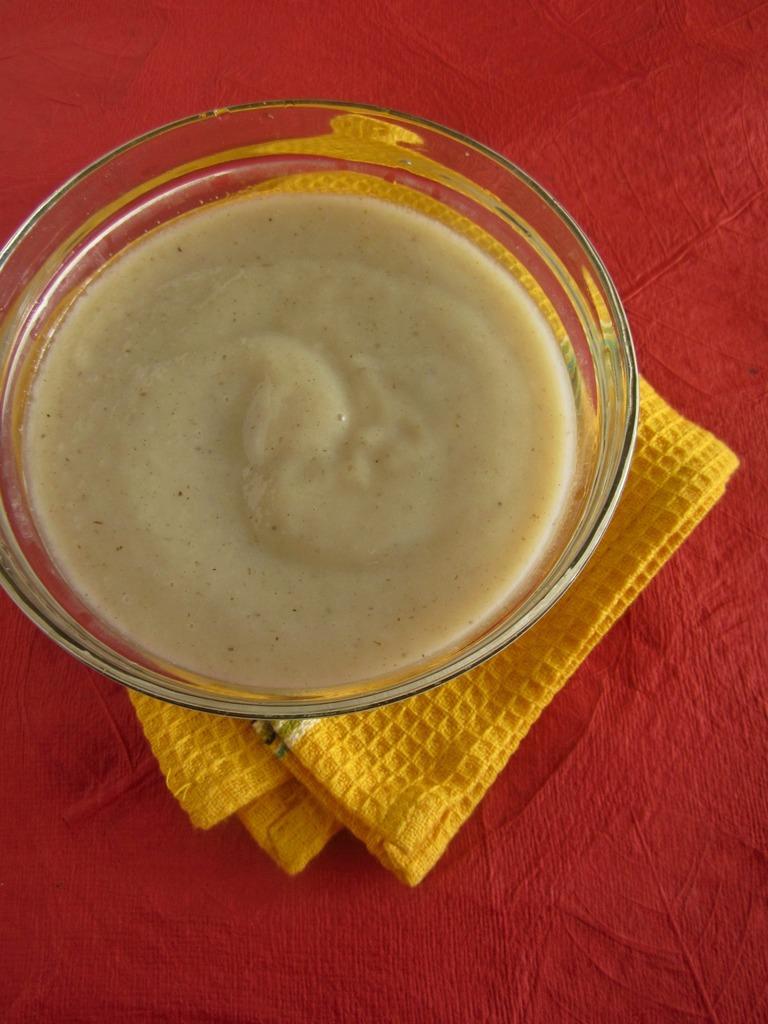Can you describe this image briefly? In this image I can see the glass bowl with food and the yellow color cloth. These are on the red color surface. 